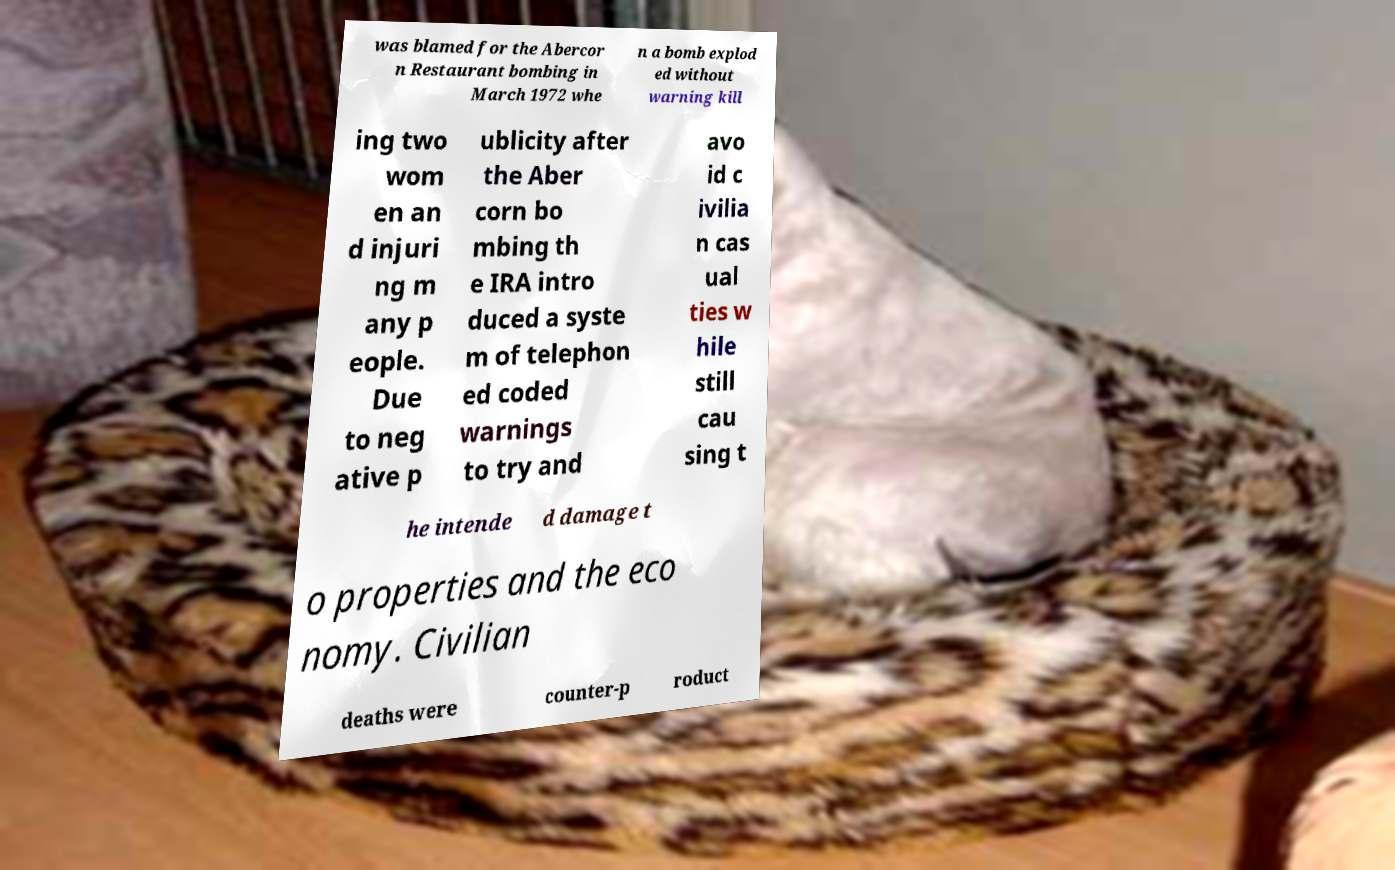For documentation purposes, I need the text within this image transcribed. Could you provide that? was blamed for the Abercor n Restaurant bombing in March 1972 whe n a bomb explod ed without warning kill ing two wom en an d injuri ng m any p eople. Due to neg ative p ublicity after the Aber corn bo mbing th e IRA intro duced a syste m of telephon ed coded warnings to try and avo id c ivilia n cas ual ties w hile still cau sing t he intende d damage t o properties and the eco nomy. Civilian deaths were counter-p roduct 